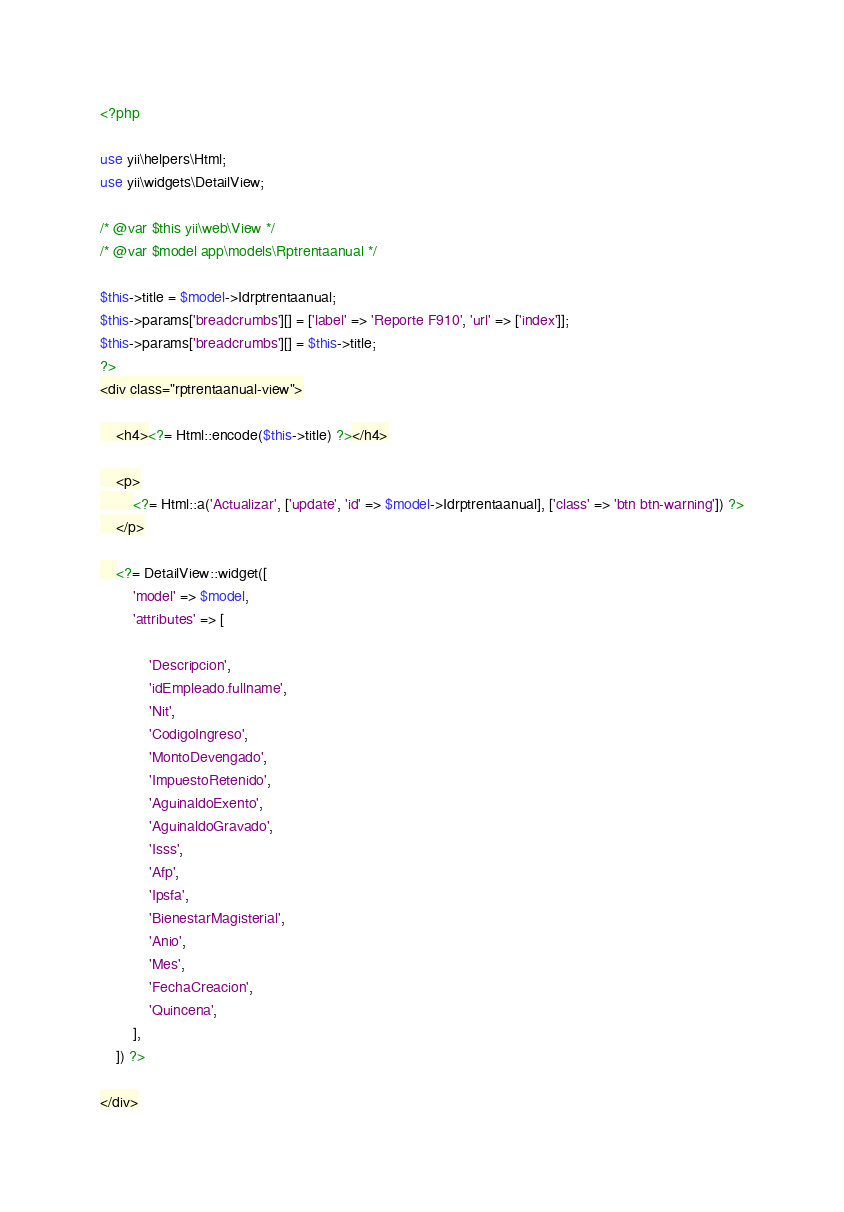Convert code to text. <code><loc_0><loc_0><loc_500><loc_500><_PHP_><?php

use yii\helpers\Html;
use yii\widgets\DetailView;

/* @var $this yii\web\View */
/* @var $model app\models\Rptrentaanual */

$this->title = $model->Idrptrentaanual;
$this->params['breadcrumbs'][] = ['label' => 'Reporte F910', 'url' => ['index']];
$this->params['breadcrumbs'][] = $this->title;
?>
<div class="rptrentaanual-view">

    <h4><?= Html::encode($this->title) ?></h4>

    <p>
        <?= Html::a('Actualizar', ['update', 'id' => $model->Idrptrentaanual], ['class' => 'btn btn-warning']) ?>
    </p>

    <?= DetailView::widget([
        'model' => $model,
        'attributes' => [

            'Descripcion',
            'idEmpleado.fullname',
            'Nit',
            'CodigoIngreso',
            'MontoDevengado',
            'ImpuestoRetenido',
            'AguinaldoExento',
            'AguinaldoGravado',
            'Isss',
            'Afp',
            'Ipsfa',
            'BienestarMagisterial',
            'Anio',
            'Mes',
            'FechaCreacion',
            'Quincena',
        ],
    ]) ?>

</div>
</code> 